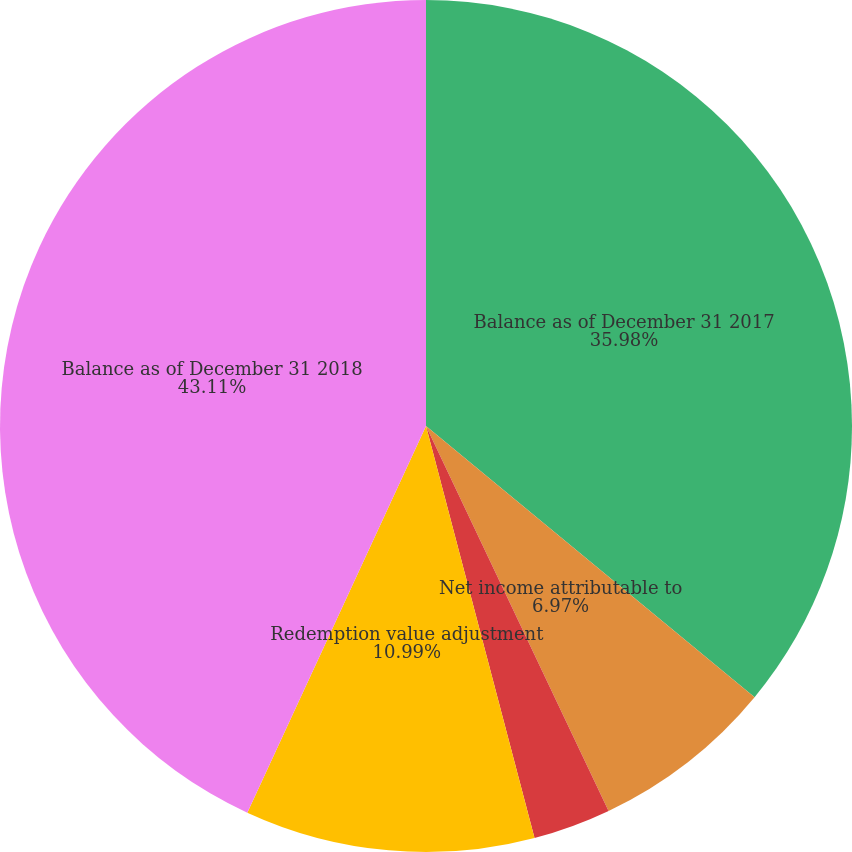<chart> <loc_0><loc_0><loc_500><loc_500><pie_chart><fcel>Balance as of December 31 2017<fcel>Net income attributable to<fcel>Distributions to<fcel>Redemption value adjustment<fcel>Balance as of December 31 2018<nl><fcel>35.98%<fcel>6.97%<fcel>2.95%<fcel>10.99%<fcel>43.11%<nl></chart> 